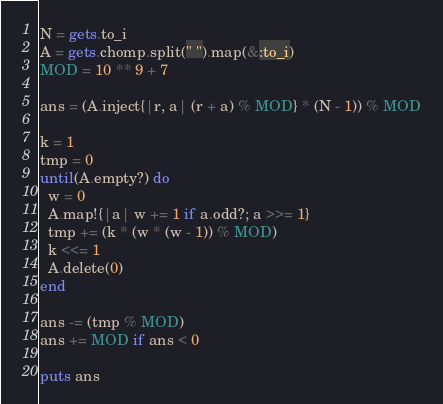<code> <loc_0><loc_0><loc_500><loc_500><_Ruby_>N = gets.to_i
A = gets.chomp.split(" ").map(&:to_i)
MOD = 10 ** 9 + 7

ans = (A.inject{|r, a| (r + a) % MOD} * (N - 1)) % MOD

k = 1
tmp = 0
until(A.empty?) do
  w = 0
  A.map!{|a| w += 1 if a.odd?; a >>= 1}
  tmp += (k * (w * (w - 1)) % MOD)
  k <<= 1
  A.delete(0)
end

ans -= (tmp % MOD)
ans += MOD if ans < 0

puts ans
</code> 